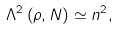Convert formula to latex. <formula><loc_0><loc_0><loc_500><loc_500>\Lambda ^ { 2 } \left ( \rho , N \right ) \simeq n ^ { 2 } ,</formula> 